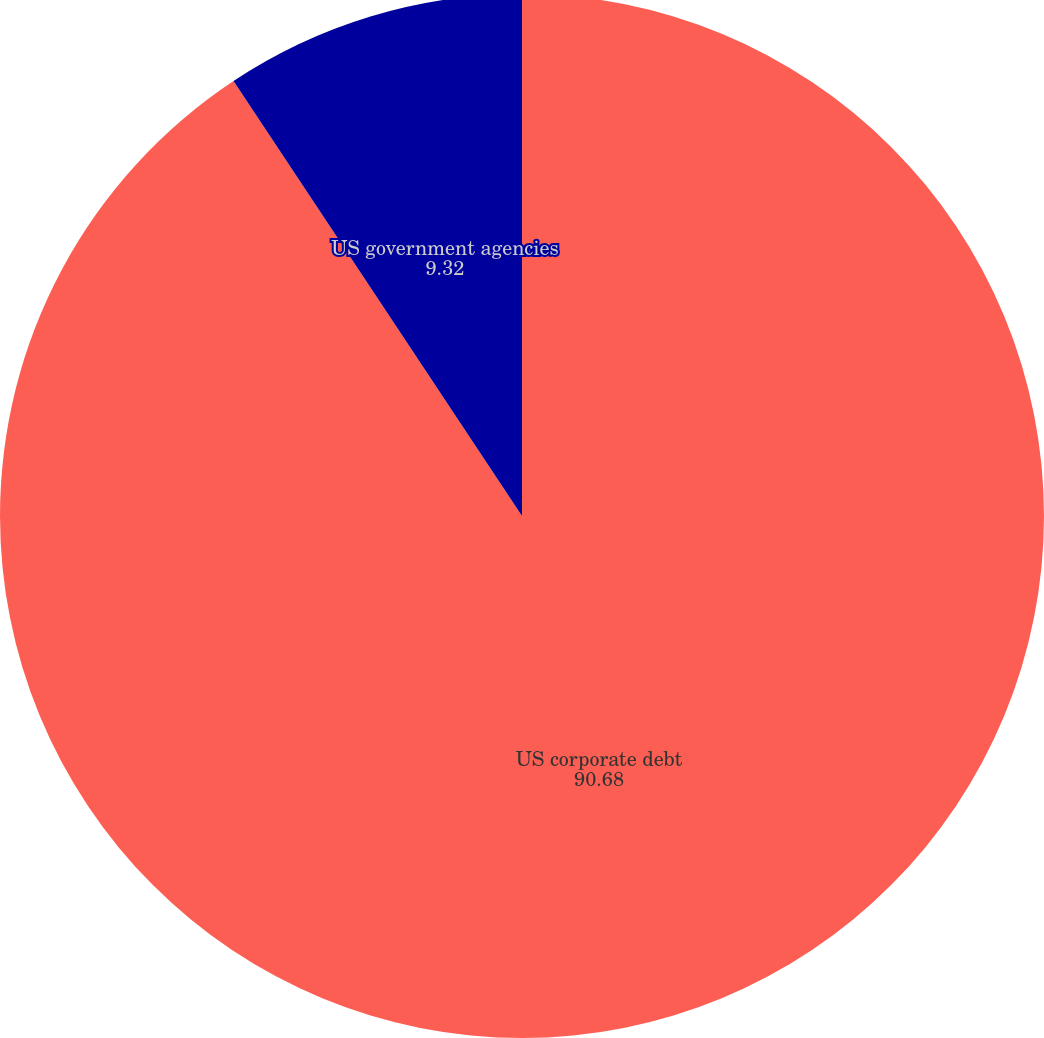Convert chart. <chart><loc_0><loc_0><loc_500><loc_500><pie_chart><fcel>US corporate debt<fcel>US government agencies<nl><fcel>90.68%<fcel>9.32%<nl></chart> 